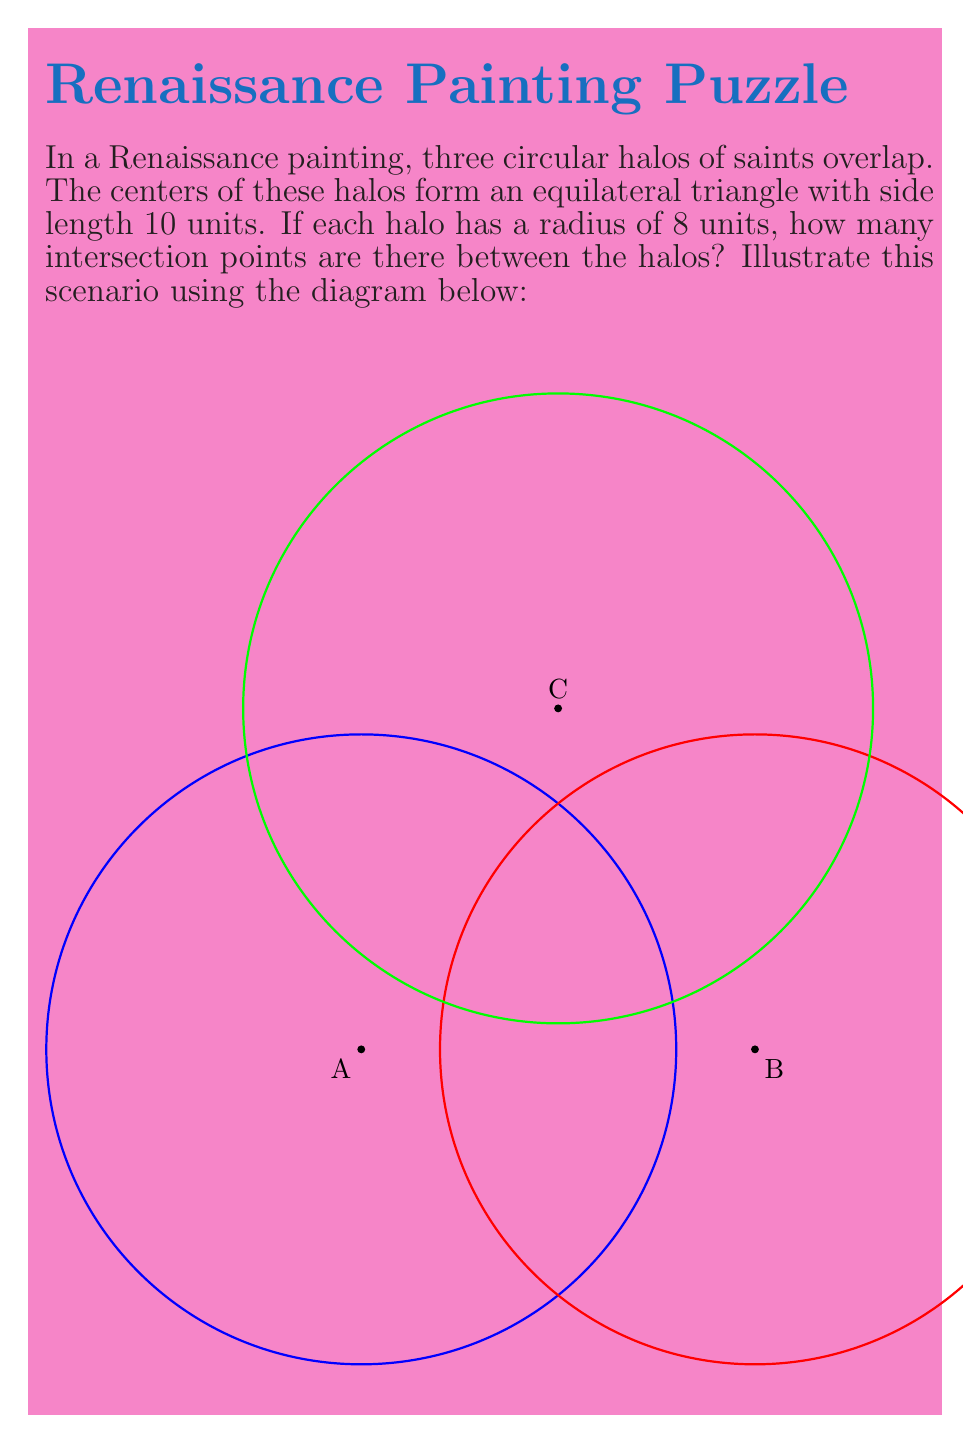Can you solve this math problem? To solve this problem, we need to analyze the intersections of the circular halos:

1) In an equilateral triangle, the distance between any two centers is equal to the side length, which is 10 units.

2) For two circles to intersect, the distance between their centers must be less than the sum of their radii but greater than the absolute difference of their radii. In this case:
   $$ \text{Distance between centers} = 10 $$
   $$ \text{Sum of radii} = 8 + 8 = 16 $$
   $$ \text{Difference of radii} = |8 - 8| = 0 $$

3) Since $0 < 10 < 16$, each pair of circles will intersect at two points.

4) There are three pairs of intersecting circles:
   - Halo A and Halo B
   - Halo B and Halo C
   - Halo C and Halo A

5) Each pair produces 2 intersection points, so the total number of intersection points is:
   $$ 3 \text{ pairs} \times 2 \text{ intersections per pair} = 6 \text{ intersection points} $$

This result aligns with the visual representation in the diagram, where we can observe 6 distinct intersection points between the three overlapping halos.
Answer: 6 intersection points 